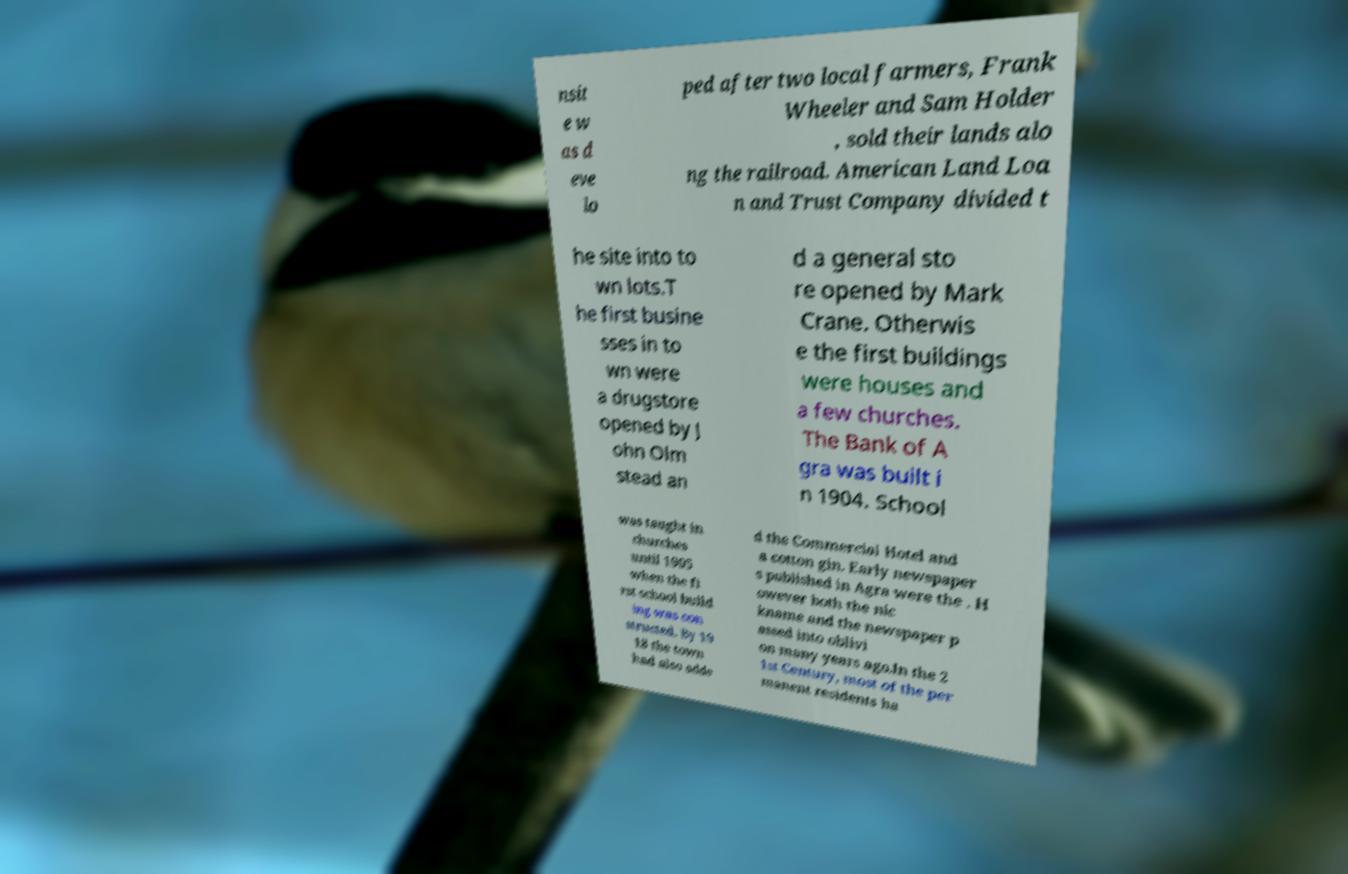Please read and relay the text visible in this image. What does it say? nsit e w as d eve lo ped after two local farmers, Frank Wheeler and Sam Holder , sold their lands alo ng the railroad. American Land Loa n and Trust Company divided t he site into to wn lots.T he first busine sses in to wn were a drugstore opened by J ohn Olm stead an d a general sto re opened by Mark Crane. Otherwis e the first buildings were houses and a few churches. The Bank of A gra was built i n 1904. School was taught in churches until 1905 when the fi rst school build ing was con structed. By 19 18 the town had also adde d the Commercial Hotel and a cotton gin. Early newspaper s published in Agra were the . H owever both the nic kname and the newspaper p assed into oblivi on many years ago.In the 2 1st Century, most of the per manent residents ha 